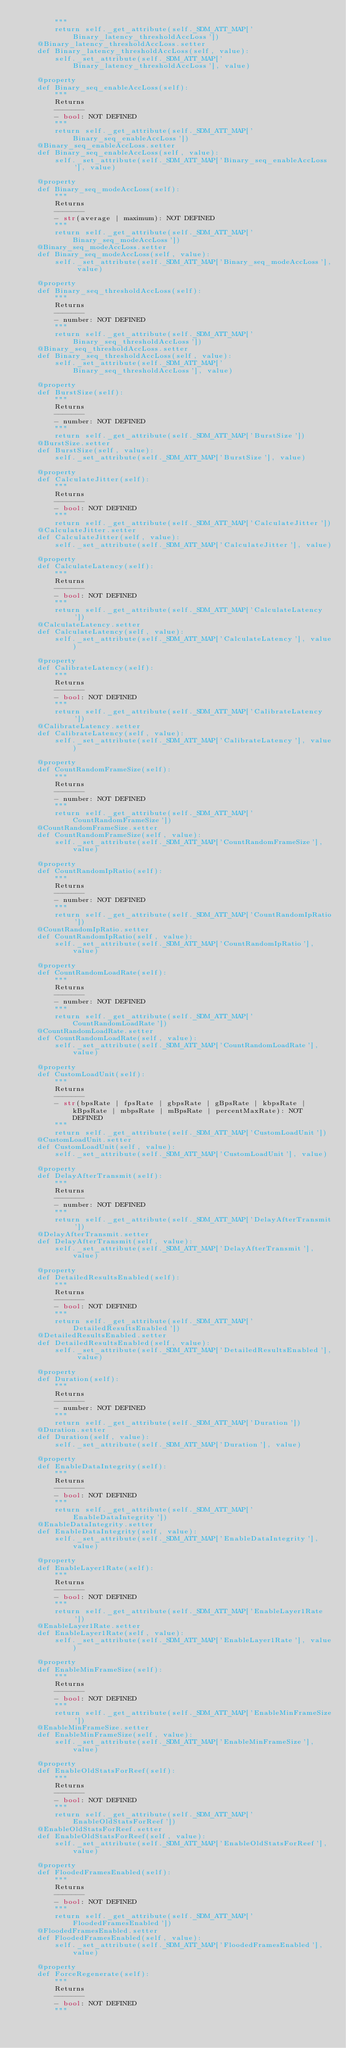<code> <loc_0><loc_0><loc_500><loc_500><_Python_>        """
        return self._get_attribute(self._SDM_ATT_MAP['Binary_latency_thresholdAccLoss'])
    @Binary_latency_thresholdAccLoss.setter
    def Binary_latency_thresholdAccLoss(self, value):
        self._set_attribute(self._SDM_ATT_MAP['Binary_latency_thresholdAccLoss'], value)

    @property
    def Binary_seq_enableAccLoss(self):
        """
        Returns
        -------
        - bool: NOT DEFINED
        """
        return self._get_attribute(self._SDM_ATT_MAP['Binary_seq_enableAccLoss'])
    @Binary_seq_enableAccLoss.setter
    def Binary_seq_enableAccLoss(self, value):
        self._set_attribute(self._SDM_ATT_MAP['Binary_seq_enableAccLoss'], value)

    @property
    def Binary_seq_modeAccLoss(self):
        """
        Returns
        -------
        - str(average | maximum): NOT DEFINED
        """
        return self._get_attribute(self._SDM_ATT_MAP['Binary_seq_modeAccLoss'])
    @Binary_seq_modeAccLoss.setter
    def Binary_seq_modeAccLoss(self, value):
        self._set_attribute(self._SDM_ATT_MAP['Binary_seq_modeAccLoss'], value)

    @property
    def Binary_seq_thresholdAccLoss(self):
        """
        Returns
        -------
        - number: NOT DEFINED
        """
        return self._get_attribute(self._SDM_ATT_MAP['Binary_seq_thresholdAccLoss'])
    @Binary_seq_thresholdAccLoss.setter
    def Binary_seq_thresholdAccLoss(self, value):
        self._set_attribute(self._SDM_ATT_MAP['Binary_seq_thresholdAccLoss'], value)

    @property
    def BurstSize(self):
        """
        Returns
        -------
        - number: NOT DEFINED
        """
        return self._get_attribute(self._SDM_ATT_MAP['BurstSize'])
    @BurstSize.setter
    def BurstSize(self, value):
        self._set_attribute(self._SDM_ATT_MAP['BurstSize'], value)

    @property
    def CalculateJitter(self):
        """
        Returns
        -------
        - bool: NOT DEFINED
        """
        return self._get_attribute(self._SDM_ATT_MAP['CalculateJitter'])
    @CalculateJitter.setter
    def CalculateJitter(self, value):
        self._set_attribute(self._SDM_ATT_MAP['CalculateJitter'], value)

    @property
    def CalculateLatency(self):
        """
        Returns
        -------
        - bool: NOT DEFINED
        """
        return self._get_attribute(self._SDM_ATT_MAP['CalculateLatency'])
    @CalculateLatency.setter
    def CalculateLatency(self, value):
        self._set_attribute(self._SDM_ATT_MAP['CalculateLatency'], value)

    @property
    def CalibrateLatency(self):
        """
        Returns
        -------
        - bool: NOT DEFINED
        """
        return self._get_attribute(self._SDM_ATT_MAP['CalibrateLatency'])
    @CalibrateLatency.setter
    def CalibrateLatency(self, value):
        self._set_attribute(self._SDM_ATT_MAP['CalibrateLatency'], value)

    @property
    def CountRandomFrameSize(self):
        """
        Returns
        -------
        - number: NOT DEFINED
        """
        return self._get_attribute(self._SDM_ATT_MAP['CountRandomFrameSize'])
    @CountRandomFrameSize.setter
    def CountRandomFrameSize(self, value):
        self._set_attribute(self._SDM_ATT_MAP['CountRandomFrameSize'], value)

    @property
    def CountRandomIpRatio(self):
        """
        Returns
        -------
        - number: NOT DEFINED
        """
        return self._get_attribute(self._SDM_ATT_MAP['CountRandomIpRatio'])
    @CountRandomIpRatio.setter
    def CountRandomIpRatio(self, value):
        self._set_attribute(self._SDM_ATT_MAP['CountRandomIpRatio'], value)

    @property
    def CountRandomLoadRate(self):
        """
        Returns
        -------
        - number: NOT DEFINED
        """
        return self._get_attribute(self._SDM_ATT_MAP['CountRandomLoadRate'])
    @CountRandomLoadRate.setter
    def CountRandomLoadRate(self, value):
        self._set_attribute(self._SDM_ATT_MAP['CountRandomLoadRate'], value)

    @property
    def CustomLoadUnit(self):
        """
        Returns
        -------
        - str(bpsRate | fpsRate | gbpsRate | gBpsRate | kbpsRate | kBpsRate | mbpsRate | mBpsRate | percentMaxRate): NOT DEFINED
        """
        return self._get_attribute(self._SDM_ATT_MAP['CustomLoadUnit'])
    @CustomLoadUnit.setter
    def CustomLoadUnit(self, value):
        self._set_attribute(self._SDM_ATT_MAP['CustomLoadUnit'], value)

    @property
    def DelayAfterTransmit(self):
        """
        Returns
        -------
        - number: NOT DEFINED
        """
        return self._get_attribute(self._SDM_ATT_MAP['DelayAfterTransmit'])
    @DelayAfterTransmit.setter
    def DelayAfterTransmit(self, value):
        self._set_attribute(self._SDM_ATT_MAP['DelayAfterTransmit'], value)

    @property
    def DetailedResultsEnabled(self):
        """
        Returns
        -------
        - bool: NOT DEFINED
        """
        return self._get_attribute(self._SDM_ATT_MAP['DetailedResultsEnabled'])
    @DetailedResultsEnabled.setter
    def DetailedResultsEnabled(self, value):
        self._set_attribute(self._SDM_ATT_MAP['DetailedResultsEnabled'], value)

    @property
    def Duration(self):
        """
        Returns
        -------
        - number: NOT DEFINED
        """
        return self._get_attribute(self._SDM_ATT_MAP['Duration'])
    @Duration.setter
    def Duration(self, value):
        self._set_attribute(self._SDM_ATT_MAP['Duration'], value)

    @property
    def EnableDataIntegrity(self):
        """
        Returns
        -------
        - bool: NOT DEFINED
        """
        return self._get_attribute(self._SDM_ATT_MAP['EnableDataIntegrity'])
    @EnableDataIntegrity.setter
    def EnableDataIntegrity(self, value):
        self._set_attribute(self._SDM_ATT_MAP['EnableDataIntegrity'], value)

    @property
    def EnableLayer1Rate(self):
        """
        Returns
        -------
        - bool: NOT DEFINED
        """
        return self._get_attribute(self._SDM_ATT_MAP['EnableLayer1Rate'])
    @EnableLayer1Rate.setter
    def EnableLayer1Rate(self, value):
        self._set_attribute(self._SDM_ATT_MAP['EnableLayer1Rate'], value)

    @property
    def EnableMinFrameSize(self):
        """
        Returns
        -------
        - bool: NOT DEFINED
        """
        return self._get_attribute(self._SDM_ATT_MAP['EnableMinFrameSize'])
    @EnableMinFrameSize.setter
    def EnableMinFrameSize(self, value):
        self._set_attribute(self._SDM_ATT_MAP['EnableMinFrameSize'], value)

    @property
    def EnableOldStatsForReef(self):
        """
        Returns
        -------
        - bool: NOT DEFINED
        """
        return self._get_attribute(self._SDM_ATT_MAP['EnableOldStatsForReef'])
    @EnableOldStatsForReef.setter
    def EnableOldStatsForReef(self, value):
        self._set_attribute(self._SDM_ATT_MAP['EnableOldStatsForReef'], value)

    @property
    def FloodedFramesEnabled(self):
        """
        Returns
        -------
        - bool: NOT DEFINED
        """
        return self._get_attribute(self._SDM_ATT_MAP['FloodedFramesEnabled'])
    @FloodedFramesEnabled.setter
    def FloodedFramesEnabled(self, value):
        self._set_attribute(self._SDM_ATT_MAP['FloodedFramesEnabled'], value)

    @property
    def ForceRegenerate(self):
        """
        Returns
        -------
        - bool: NOT DEFINED
        """</code> 